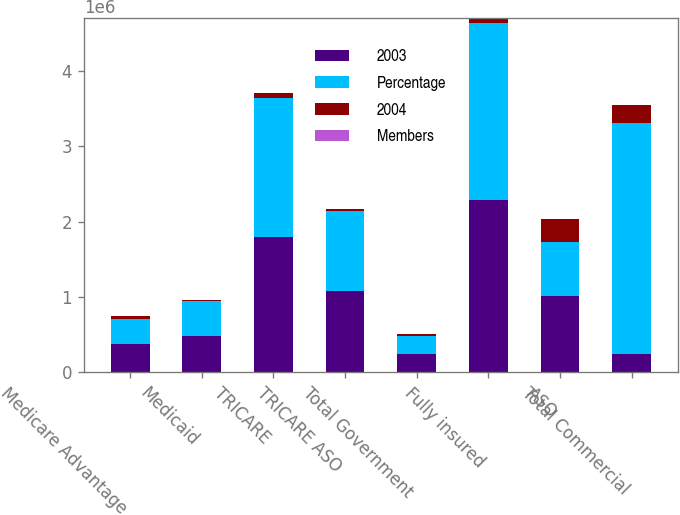<chart> <loc_0><loc_0><loc_500><loc_500><stacked_bar_chart><ecel><fcel>Medicare Advantage<fcel>Medicaid<fcel>TRICARE<fcel>TRICARE ASO<fcel>Total Government<fcel>Fully insured<fcel>ASO<fcel>Total Commercial<nl><fcel>2003<fcel>377200<fcel>478600<fcel>1.7894e+06<fcel>1.0824e+06<fcel>239900<fcel>2.2865e+06<fcel>1.0186e+06<fcel>239900<nl><fcel>Percentage<fcel>328600<fcel>468900<fcel>1.8497e+06<fcel>1.0572e+06<fcel>239900<fcel>2.3528e+06<fcel>712400<fcel>3.0652e+06<nl><fcel>2004<fcel>48600<fcel>9700<fcel>60300<fcel>25200<fcel>23200<fcel>66300<fcel>306200<fcel>239900<nl><fcel>Members<fcel>14.8<fcel>2.1<fcel>3.3<fcel>2.4<fcel>0.6<fcel>2.8<fcel>43<fcel>7.8<nl></chart> 